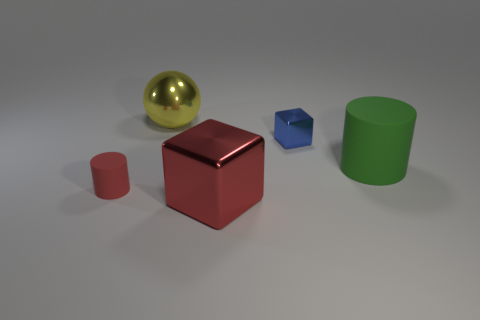What is the shape of the large metal thing that is the same color as the small rubber thing?
Give a very brief answer. Cube. Are there any big blocks of the same color as the small rubber cylinder?
Offer a terse response. Yes. Does the large thing in front of the large green matte object have the same color as the tiny matte cylinder?
Your answer should be compact. Yes. Are there more cylinders that are in front of the tiny blue metal object than metallic balls to the right of the shiny ball?
Your response must be concise. Yes. What is the cube that is behind the large rubber cylinder that is on the right side of the shiny cube that is left of the blue metal cube made of?
Your response must be concise. Metal. What is the shape of the large thing that is the same material as the ball?
Give a very brief answer. Cube. Is there a green rubber object in front of the shiny thing behind the tiny metal block?
Give a very brief answer. Yes. What is the size of the shiny ball?
Your answer should be compact. Large. What number of things are small red rubber cylinders or metallic cubes?
Offer a terse response. 3. Is the material of the small thing that is behind the small rubber object the same as the big thing in front of the big rubber cylinder?
Your answer should be compact. Yes. 